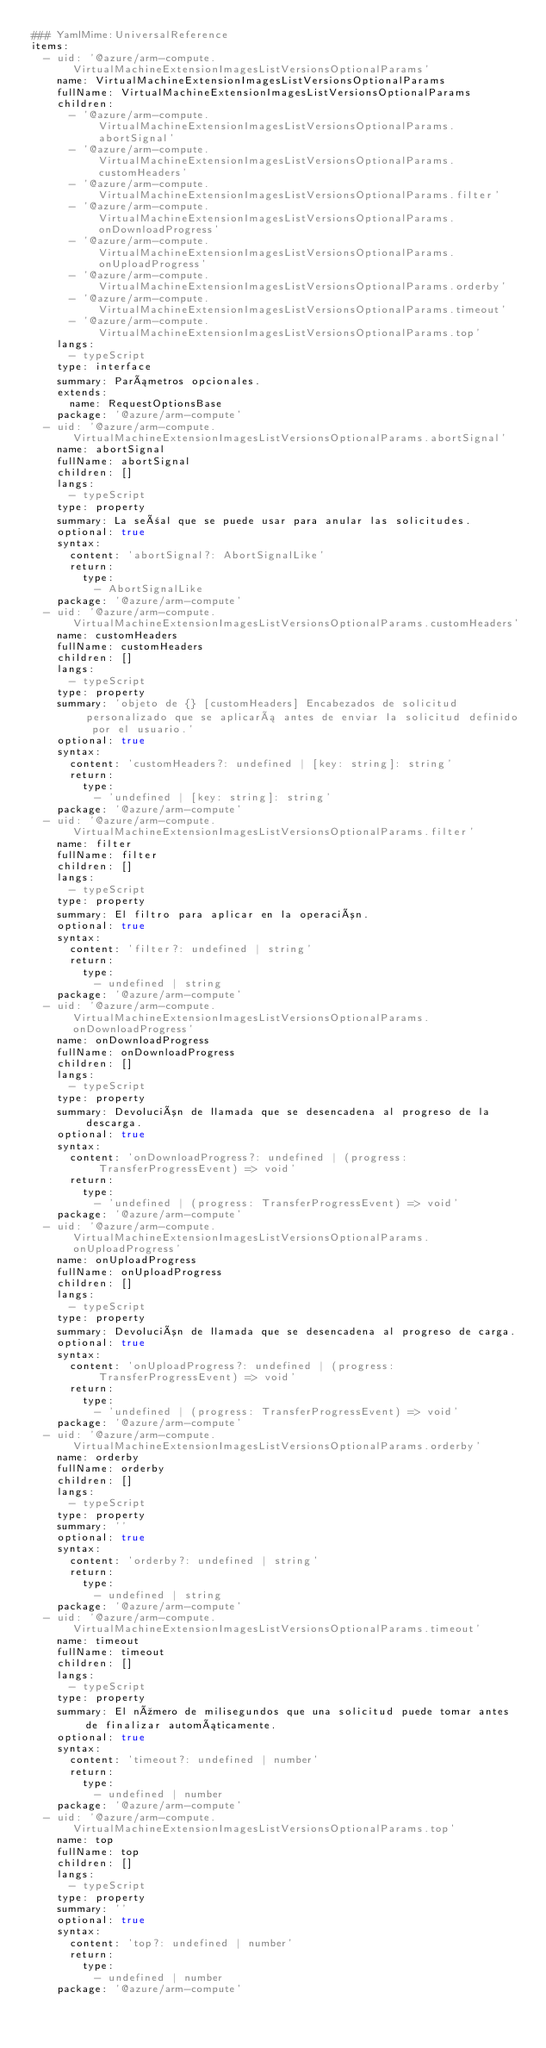<code> <loc_0><loc_0><loc_500><loc_500><_YAML_>### YamlMime:UniversalReference
items:
  - uid: '@azure/arm-compute.VirtualMachineExtensionImagesListVersionsOptionalParams'
    name: VirtualMachineExtensionImagesListVersionsOptionalParams
    fullName: VirtualMachineExtensionImagesListVersionsOptionalParams
    children:
      - '@azure/arm-compute.VirtualMachineExtensionImagesListVersionsOptionalParams.abortSignal'
      - '@azure/arm-compute.VirtualMachineExtensionImagesListVersionsOptionalParams.customHeaders'
      - '@azure/arm-compute.VirtualMachineExtensionImagesListVersionsOptionalParams.filter'
      - '@azure/arm-compute.VirtualMachineExtensionImagesListVersionsOptionalParams.onDownloadProgress'
      - '@azure/arm-compute.VirtualMachineExtensionImagesListVersionsOptionalParams.onUploadProgress'
      - '@azure/arm-compute.VirtualMachineExtensionImagesListVersionsOptionalParams.orderby'
      - '@azure/arm-compute.VirtualMachineExtensionImagesListVersionsOptionalParams.timeout'
      - '@azure/arm-compute.VirtualMachineExtensionImagesListVersionsOptionalParams.top'
    langs:
      - typeScript
    type: interface
    summary: Parámetros opcionales.
    extends:
      name: RequestOptionsBase
    package: '@azure/arm-compute'
  - uid: '@azure/arm-compute.VirtualMachineExtensionImagesListVersionsOptionalParams.abortSignal'
    name: abortSignal
    fullName: abortSignal
    children: []
    langs:
      - typeScript
    type: property
    summary: La señal que se puede usar para anular las solicitudes.
    optional: true
    syntax:
      content: 'abortSignal?: AbortSignalLike'
      return:
        type:
          - AbortSignalLike
    package: '@azure/arm-compute'
  - uid: '@azure/arm-compute.VirtualMachineExtensionImagesListVersionsOptionalParams.customHeaders'
    name: customHeaders
    fullName: customHeaders
    children: []
    langs:
      - typeScript
    type: property
    summary: 'objeto de {} [customHeaders] Encabezados de solicitud personalizado que se aplicará antes de enviar la solicitud definido por el usuario.'
    optional: true
    syntax:
      content: 'customHeaders?: undefined | [key: string]: string'
      return:
        type:
          - 'undefined | [key: string]: string'
    package: '@azure/arm-compute'
  - uid: '@azure/arm-compute.VirtualMachineExtensionImagesListVersionsOptionalParams.filter'
    name: filter
    fullName: filter
    children: []
    langs:
      - typeScript
    type: property
    summary: El filtro para aplicar en la operación.
    optional: true
    syntax:
      content: 'filter?: undefined | string'
      return:
        type:
          - undefined | string
    package: '@azure/arm-compute'
  - uid: '@azure/arm-compute.VirtualMachineExtensionImagesListVersionsOptionalParams.onDownloadProgress'
    name: onDownloadProgress
    fullName: onDownloadProgress
    children: []
    langs:
      - typeScript
    type: property
    summary: Devolución de llamada que se desencadena al progreso de la descarga.
    optional: true
    syntax:
      content: 'onDownloadProgress?: undefined | (progress: TransferProgressEvent) => void'
      return:
        type:
          - 'undefined | (progress: TransferProgressEvent) => void'
    package: '@azure/arm-compute'
  - uid: '@azure/arm-compute.VirtualMachineExtensionImagesListVersionsOptionalParams.onUploadProgress'
    name: onUploadProgress
    fullName: onUploadProgress
    children: []
    langs:
      - typeScript
    type: property
    summary: Devolución de llamada que se desencadena al progreso de carga.
    optional: true
    syntax:
      content: 'onUploadProgress?: undefined | (progress: TransferProgressEvent) => void'
      return:
        type:
          - 'undefined | (progress: TransferProgressEvent) => void'
    package: '@azure/arm-compute'
  - uid: '@azure/arm-compute.VirtualMachineExtensionImagesListVersionsOptionalParams.orderby'
    name: orderby
    fullName: orderby
    children: []
    langs:
      - typeScript
    type: property
    summary: ''
    optional: true
    syntax:
      content: 'orderby?: undefined | string'
      return:
        type:
          - undefined | string
    package: '@azure/arm-compute'
  - uid: '@azure/arm-compute.VirtualMachineExtensionImagesListVersionsOptionalParams.timeout'
    name: timeout
    fullName: timeout
    children: []
    langs:
      - typeScript
    type: property
    summary: El número de milisegundos que una solicitud puede tomar antes de finalizar automáticamente.
    optional: true
    syntax:
      content: 'timeout?: undefined | number'
      return:
        type:
          - undefined | number
    package: '@azure/arm-compute'
  - uid: '@azure/arm-compute.VirtualMachineExtensionImagesListVersionsOptionalParams.top'
    name: top
    fullName: top
    children: []
    langs:
      - typeScript
    type: property
    summary: ''
    optional: true
    syntax:
      content: 'top?: undefined | number'
      return:
        type:
          - undefined | number
    package: '@azure/arm-compute'</code> 